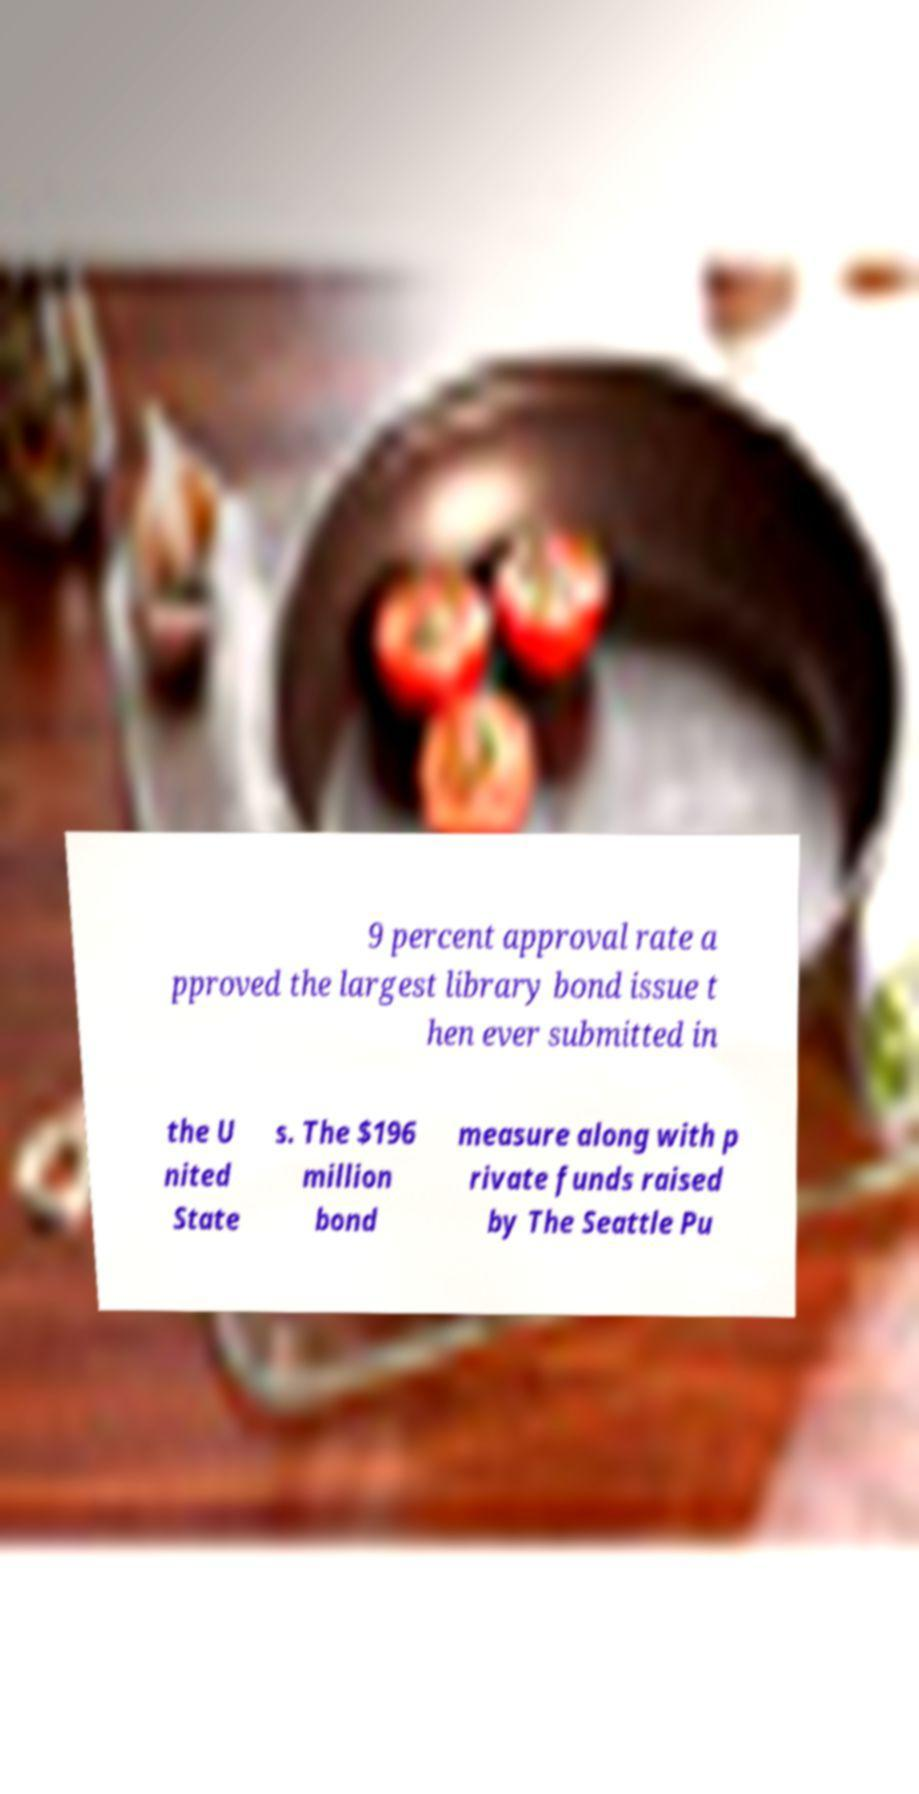Can you accurately transcribe the text from the provided image for me? 9 percent approval rate a pproved the largest library bond issue t hen ever submitted in the U nited State s. The $196 million bond measure along with p rivate funds raised by The Seattle Pu 